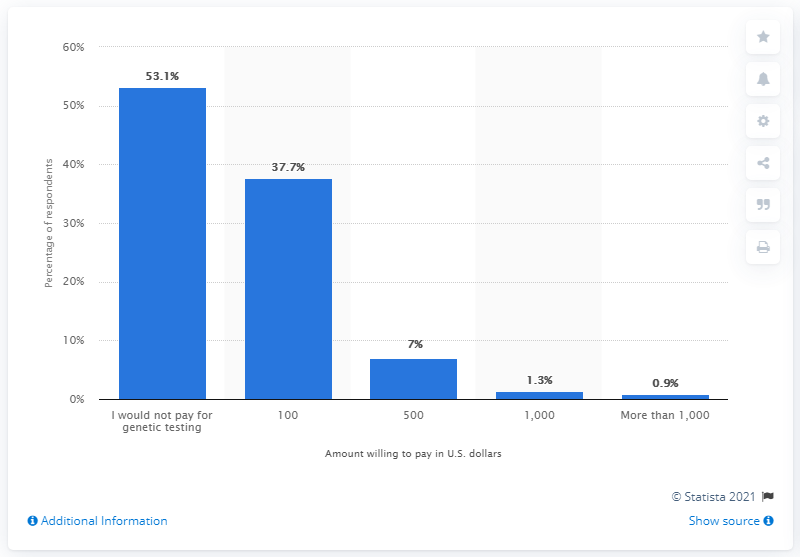What did 37.7 percent of Americans say they would pay for genetic testing?
 100 